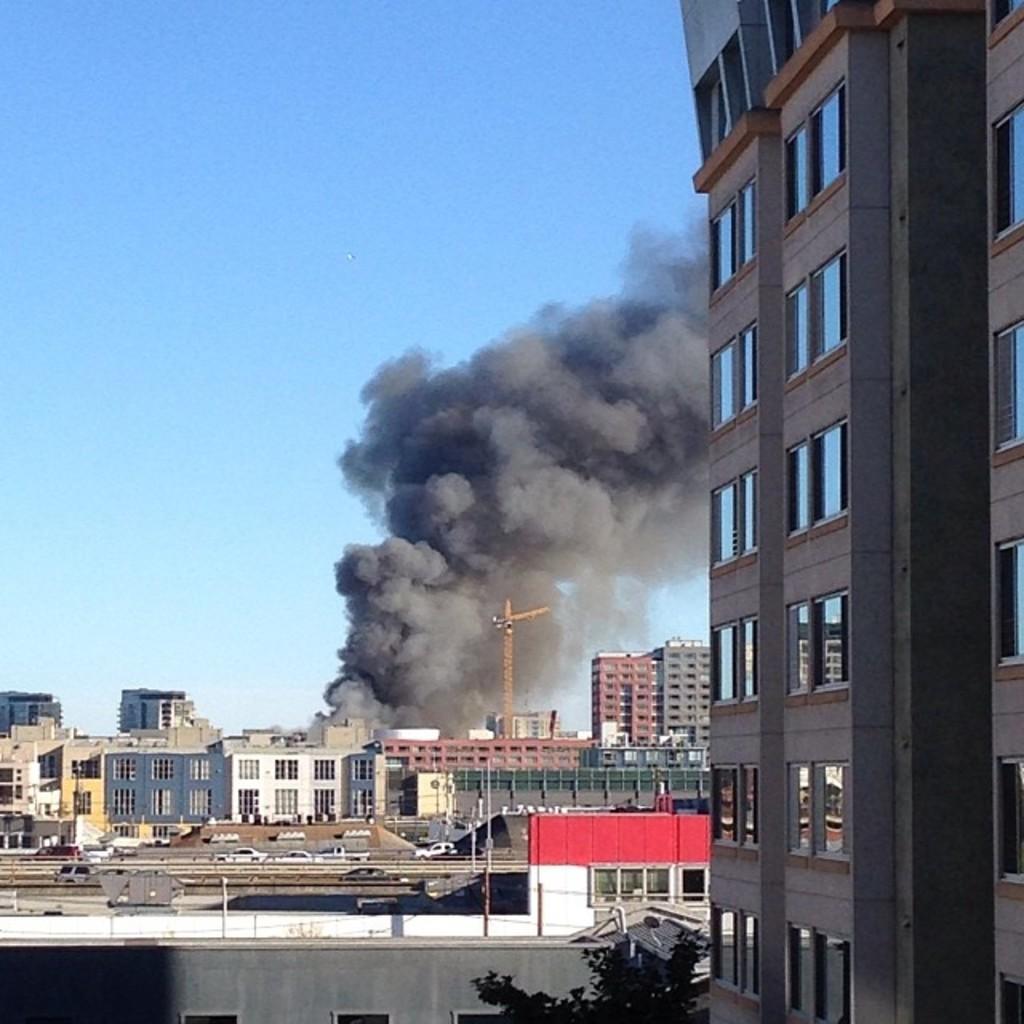In one or two sentences, can you explain what this image depicts? There are buildings, poles and the smoke in the foreground area of the image and the sky in the background. 